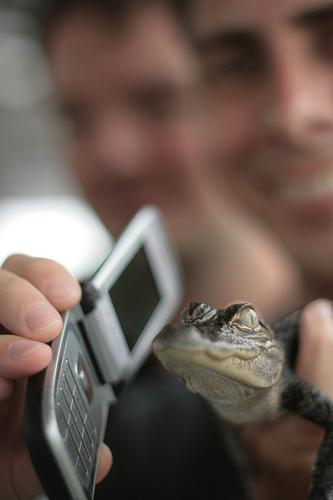Question: where is the cell phone?
Choices:
A. On the table.
B. Next to the baby alligator.
C. In his hand.
D. In the store.
Answer with the letter. Answer: B Question: what emotion does the man have on his face?
Choices:
A. Sadness.
B. Love.
C. Shock.
D. Happiness.
Answer with the letter. Answer: D Question: who is holding the cellphone and baby alligator?
Choices:
A. Nobody.
B. The woman.
C. One of the men.
D. The alligator handler.
Answer with the letter. Answer: C Question: how many things are the man holding?
Choices:
A. Six.
B. One.
C. Three.
D. Two.
Answer with the letter. Answer: D Question: what animal is the man holding?
Choices:
A. A cat.
B. A dog.
C. A baby alligator.
D. A snake.
Answer with the letter. Answer: C 